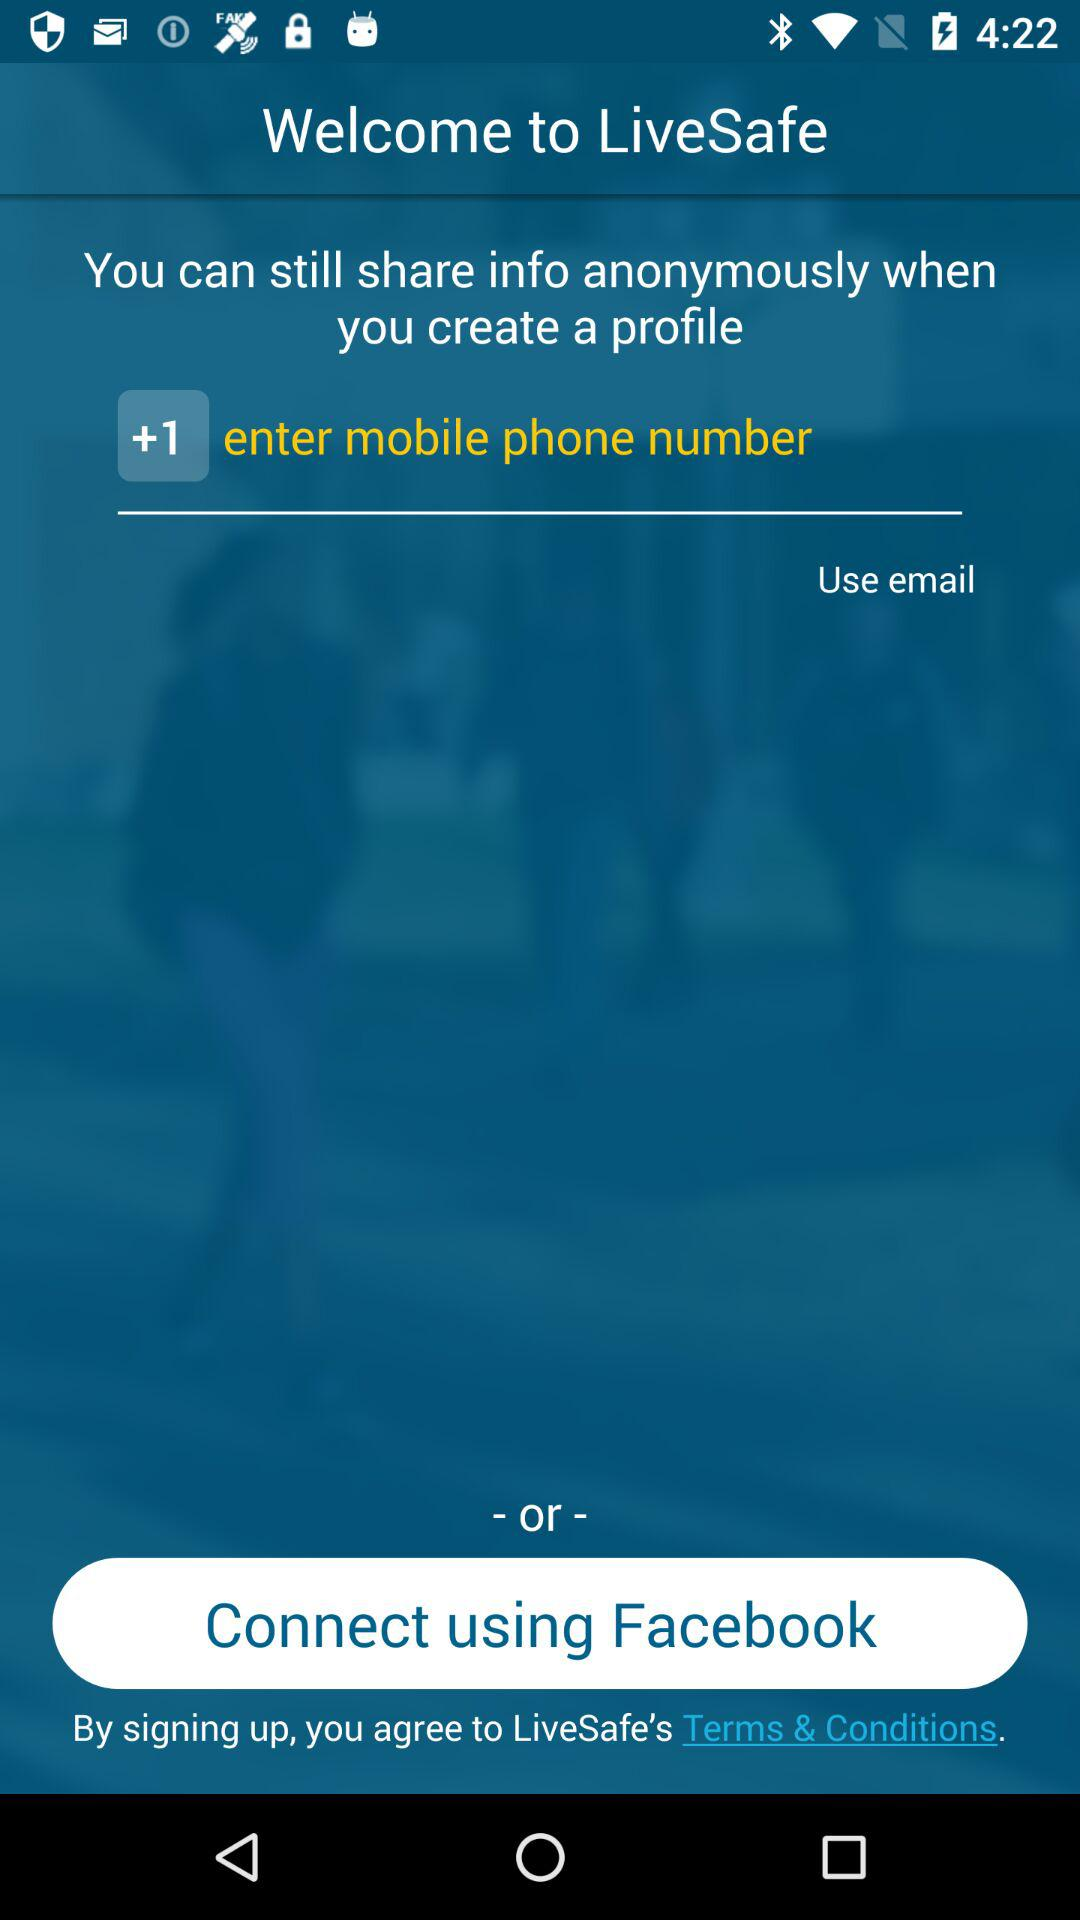What is the name of the application? The name of the application is "LiveSafe". 